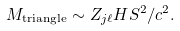<formula> <loc_0><loc_0><loc_500><loc_500>M _ { \text {triangle} } \sim Z _ { j \ell } H S ^ { 2 } / c ^ { 2 } .</formula> 